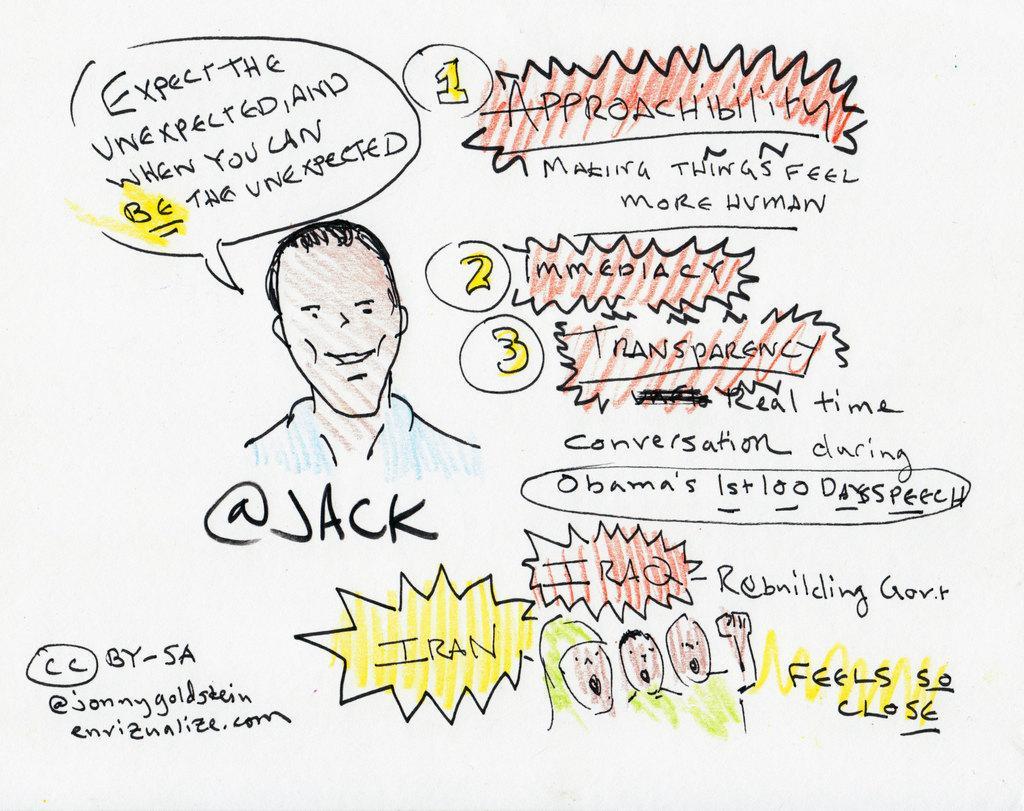Describe this image in one or two sentences. In this image there is a white wall on which text is written, there is a drawing of the persons on the wall. 